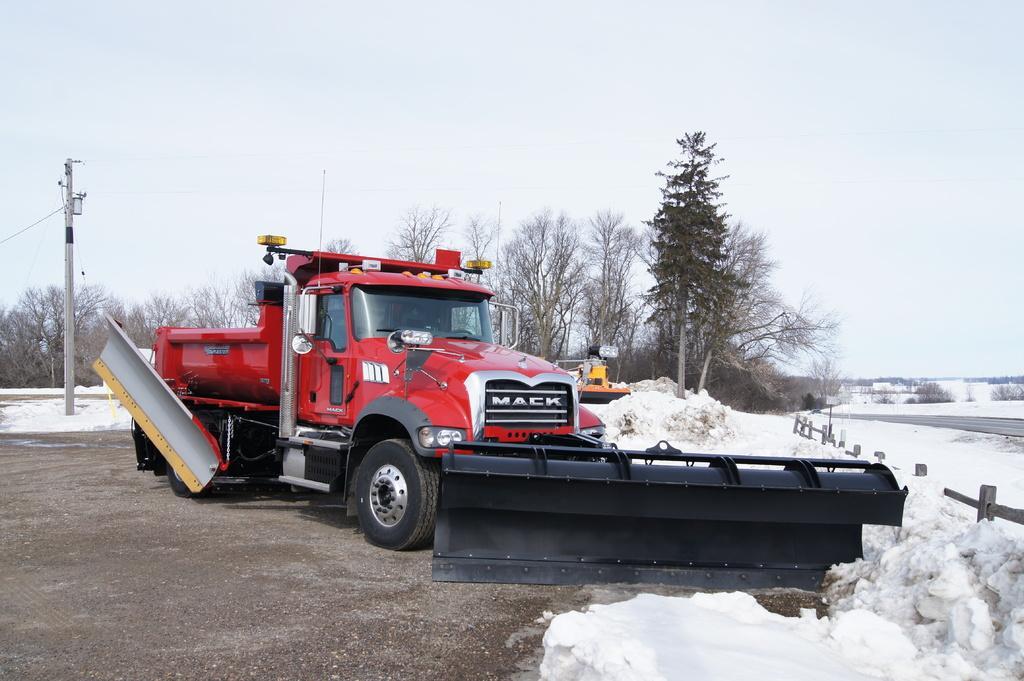Describe this image in one or two sentences. Here we can see a vehicle. This is snow and there is a fence. In the background we can see trees, pole, and sky. 